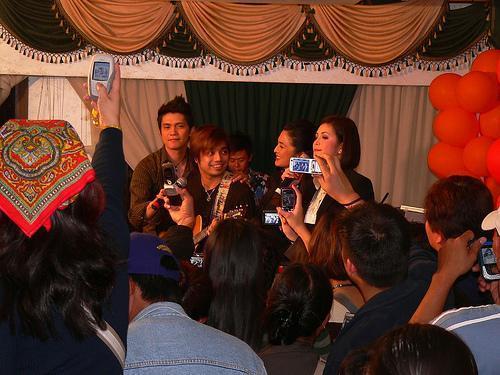How many people are on the stage?
Give a very brief answer. 5. How many people are wearing red bandanas on their heads?
Give a very brief answer. 1. 